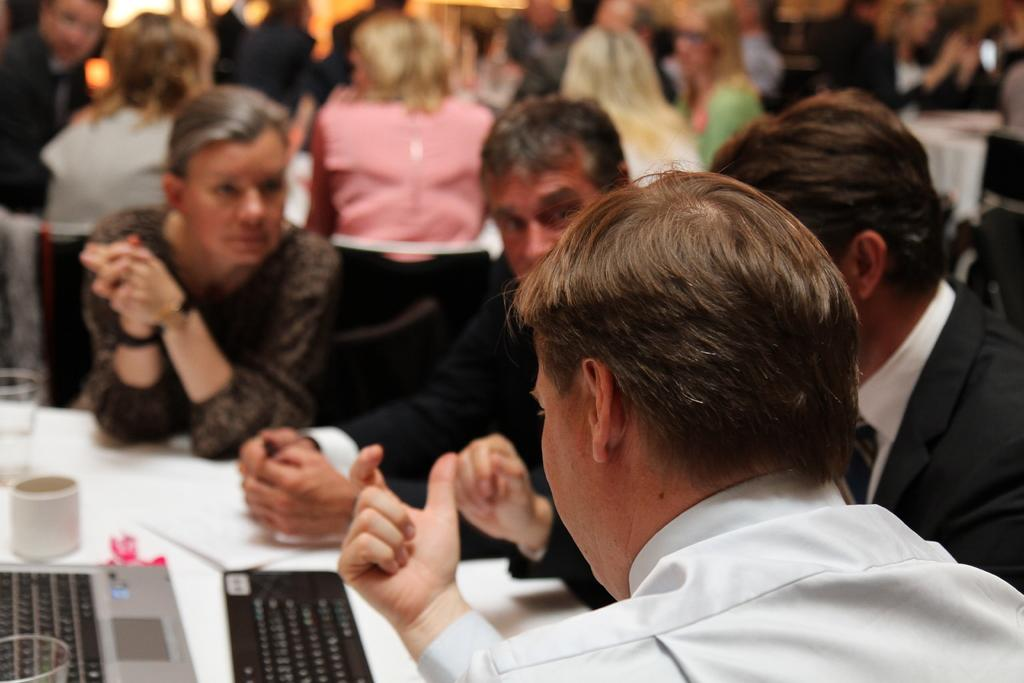What are the people in the image doing? There is a group of persons sitting on chairs in the image. What can be seen in the image besides the people sitting on chairs? There are tables in the image. Can you describe the objects on a table in the bottom left of the image? Unfortunately, the facts provided do not give any information about the objects on the table in the bottom left of the image. What type of prison can be seen in the background of the image? There is no prison present in the image. How many cords are connected to the chairs in the image? There is no information about cords in the image. 